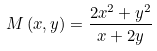Convert formula to latex. <formula><loc_0><loc_0><loc_500><loc_500>M \left ( x , y \right ) = \frac { 2 x ^ { 2 } + y ^ { 2 } } { x + 2 y }</formula> 